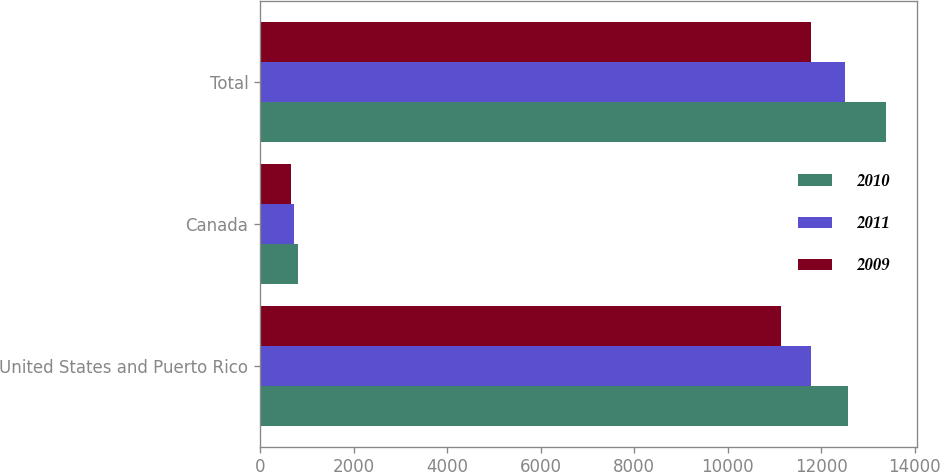Convert chart. <chart><loc_0><loc_0><loc_500><loc_500><stacked_bar_chart><ecel><fcel>United States and Puerto Rico<fcel>Canada<fcel>Total<nl><fcel>2010<fcel>12578<fcel>800<fcel>13378<nl><fcel>2011<fcel>11784<fcel>731<fcel>12515<nl><fcel>2009<fcel>11137<fcel>654<fcel>11791<nl></chart> 